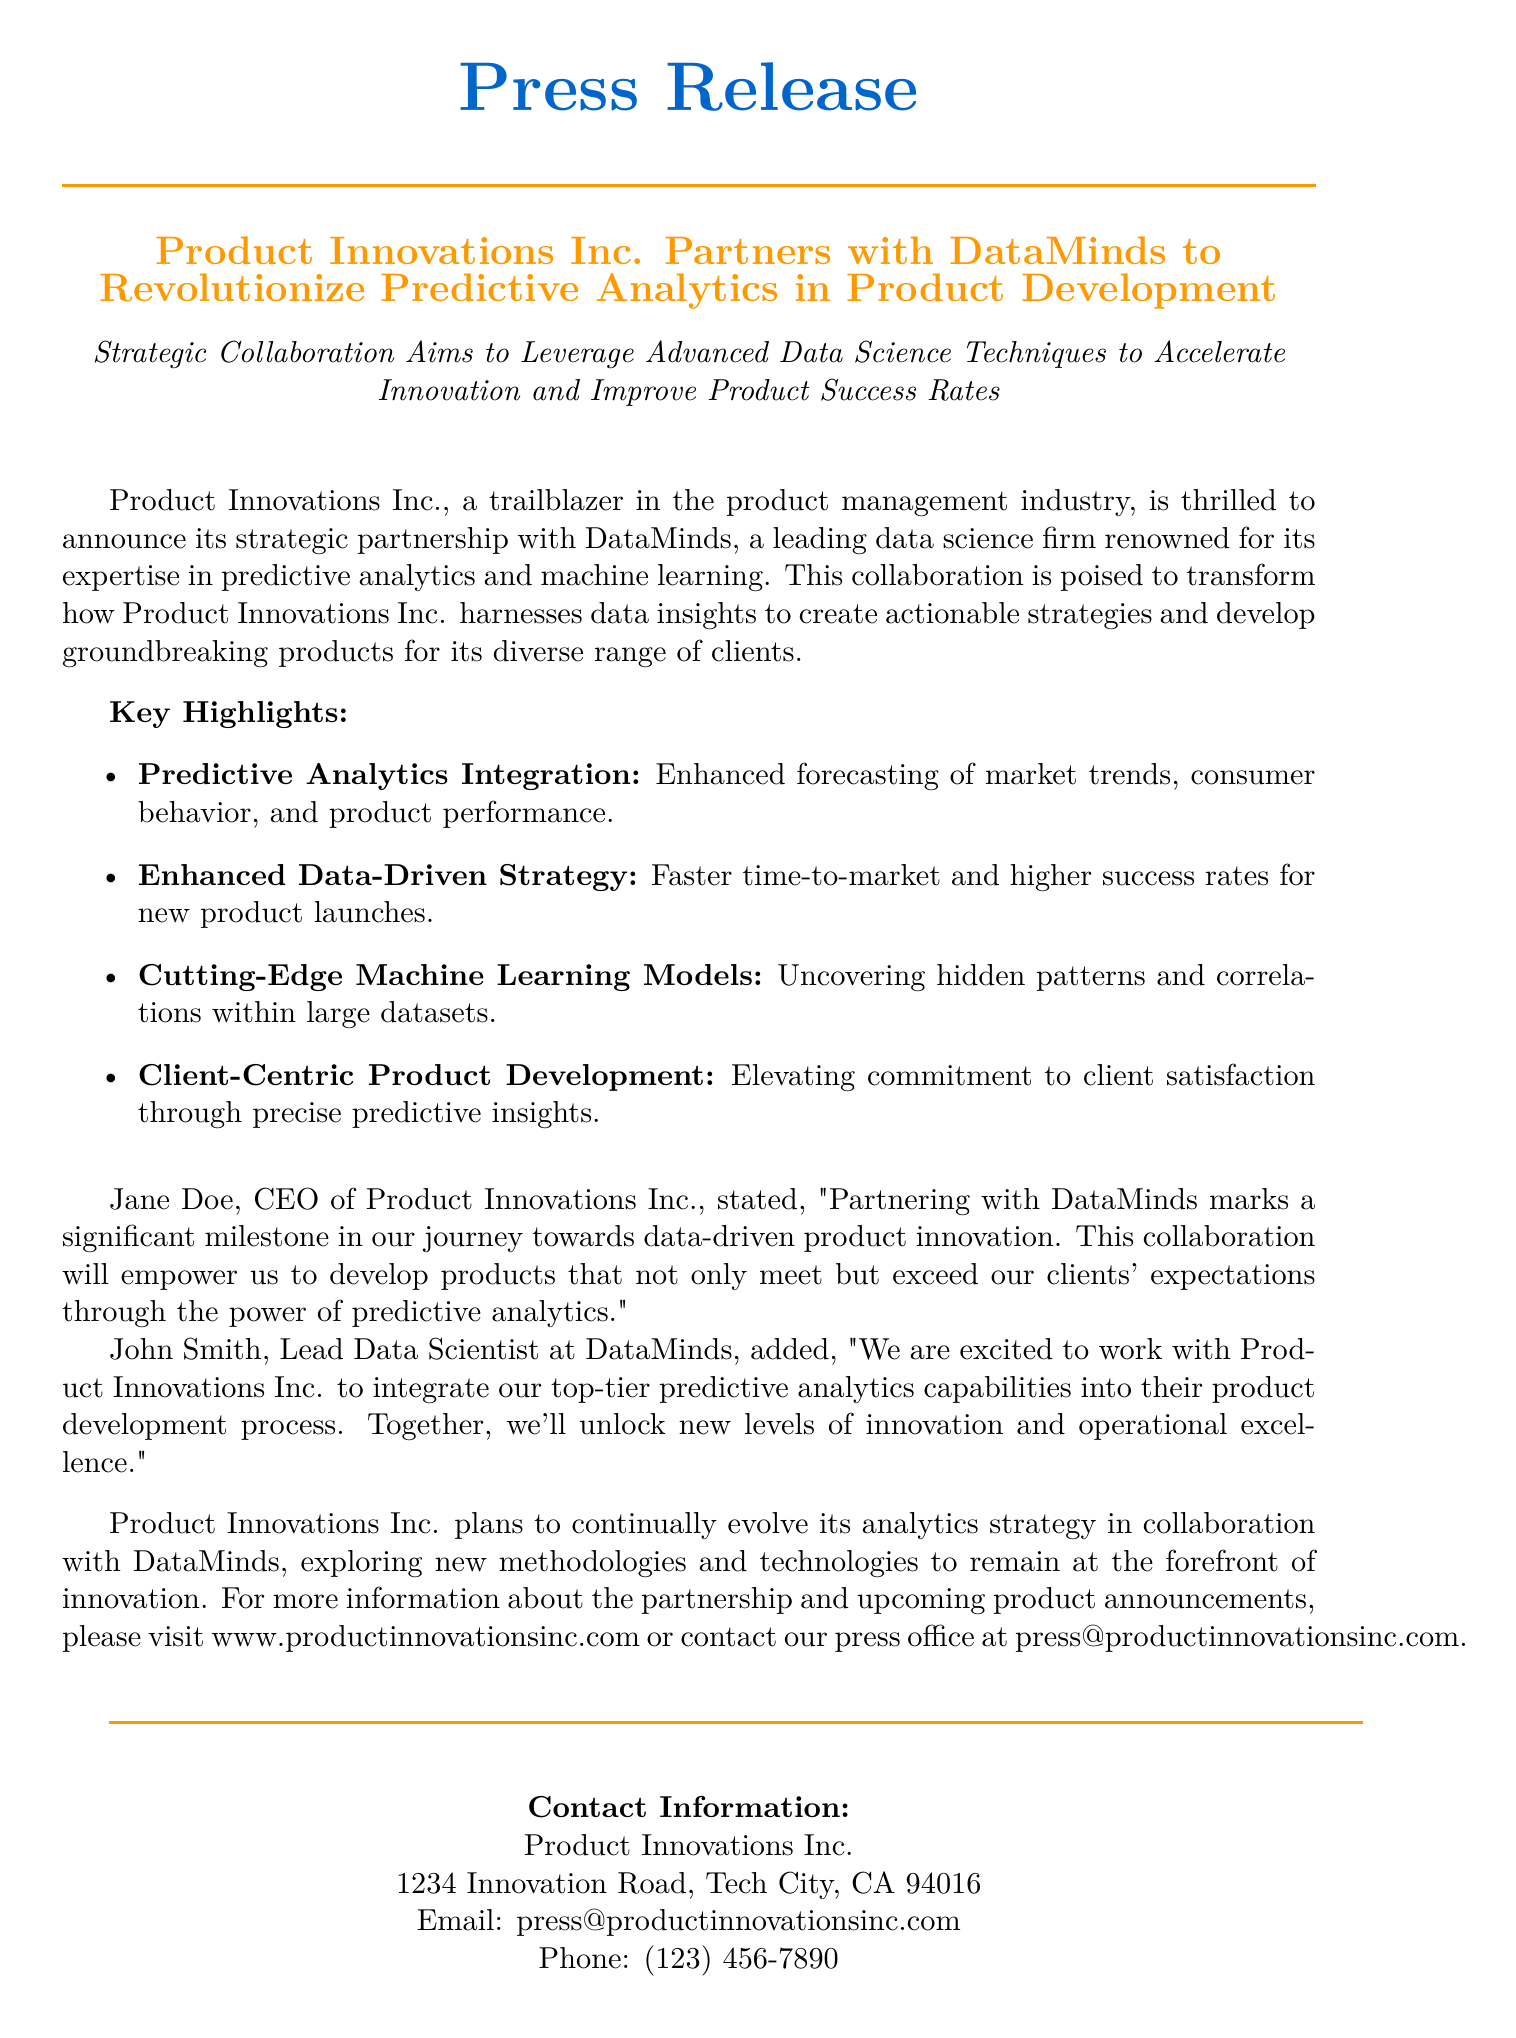What is the name of the product management company? The document states that the product management company is called Product Innovations Inc.
Answer: Product Innovations Inc Who is the CEO of Product Innovations Inc.? According to the document, the CEO of Product Innovations Inc. is Jane Doe.
Answer: Jane Doe What is the main goal of the collaboration with DataMinds? The document mentions that the collaboration aims to leverage advanced data science techniques to accelerate innovation and improve product success rates.
Answer: Enhance predictive analytics What type of analytics is being integrated? The document explicitly states that predictive analytics is being integrated into the product development process.
Answer: Predictive analytics What is the location of Product Innovations Inc.? The document provides the address 1234 Innovation Road, Tech City, CA 94016 for Product Innovations Inc.
Answer: 1234 Innovation Road, Tech City, CA 94016 Who is the Lead Data Scientist at DataMinds? The document identifies John Smith as the Lead Data Scientist at DataMinds.
Answer: John Smith What is a key highlight regarding product launches? The document highlights that there will be a faster time-to-market and higher success rates for new product launches due to the collaboration.
Answer: Faster time-to-market What aspect of product development does the partnership focus on? The partnership focuses on client-centric product development and enhancing commitment to client satisfaction through predictive insights.
Answer: Client-centric product development How can interested parties get more information about the partnership? The document suggests visiting the website www.productinnovationsinc.com or contacting the press office for more information.
Answer: www.productinnovationsinc.com 